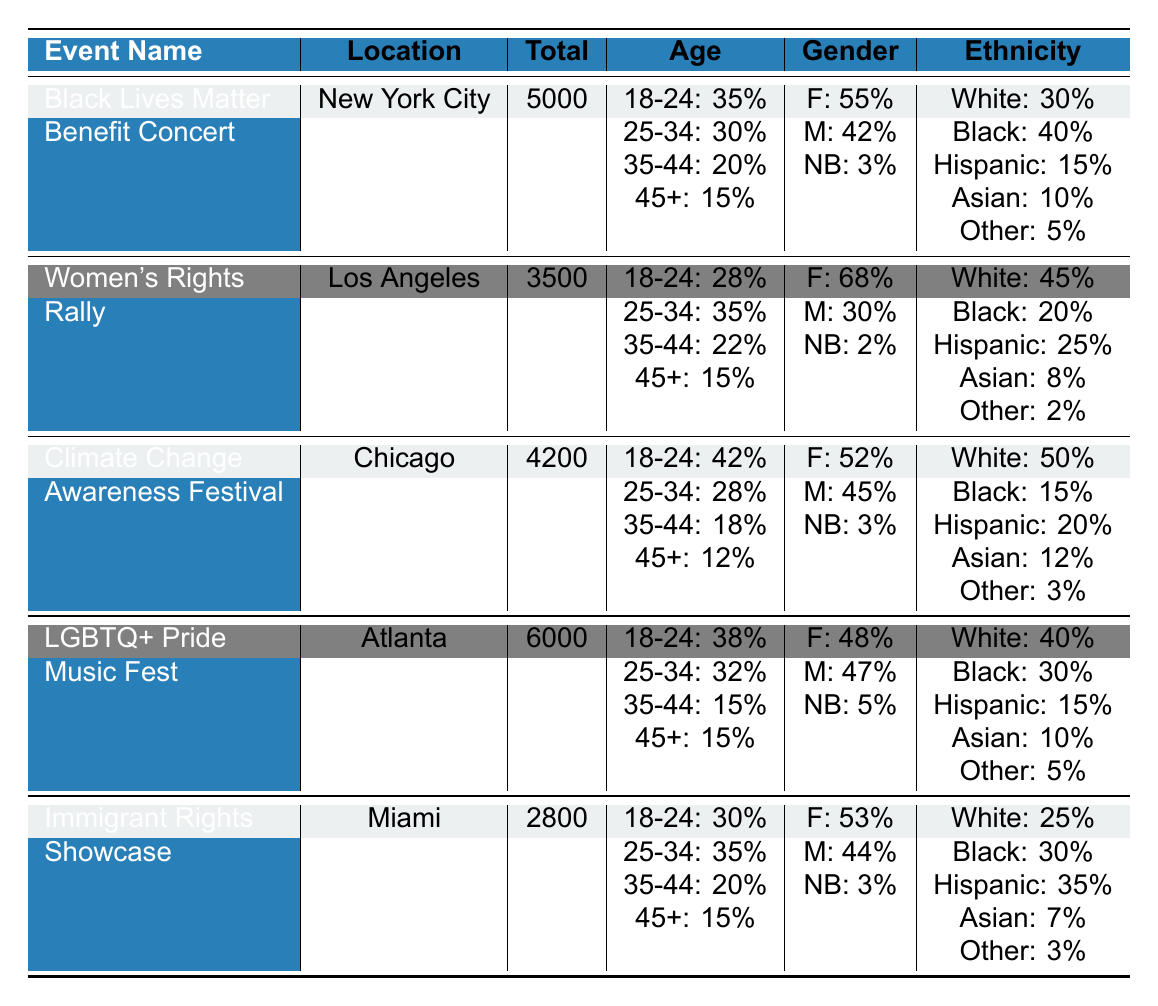What is the total number of attendees at the Women's Rights Rally? The total number of attendees is provided in the "Total Attendees" column for the Women's Rights Rally, which shows 3500 attendees.
Answer: 3500 Which event had the highest percentage of attendees aged 18-24? The "Age 18-24 Percentage" column shows the values: 35%, 28%, 42%, 38%, and 30%. The highest value is 42%, which corresponds to the Climate Change Awareness Festival.
Answer: Climate Change Awareness Festival What percentage of attendees at the LGBTQ+ Pride Music Fest identified as male? Referring to the "Male Percentage" column, the value provided for the LGBTQ+ Pride Music Fest is 47%.
Answer: 47% Is the majority of attendees at the Black Lives Matter Benefit Concert female? The "Female Percentage" for the Black Lives Matter Benefit Concert is 55%, which is greater than 50%, indicating that the majority are female.
Answer: Yes How many more attendees were there at the LGBTQ+ Pride Music Fest compared to the Immigrant Rights Showcase? The total attendees for the LGBTQ+ Pride Music Fest is 6000, while for the Immigrant Rights Showcase, it is 2800. The difference is 6000 - 2800 = 3200.
Answer: 3200 What is the average percentage of Hispanic attendees across all events? The percentages of Hispanic attendees are 15%, 25%, 20%, 15%, and 35%. Adding these gives 15 + 25 + 20 + 15 + 35 = 110. Dividing this by 5 gives an average of 110 / 5 = 22%.
Answer: 22% Which event had the lowest percentage of Asian attendees? The "Asian Percentage" values are 10%, 8%, 12%, 10%, and 7%. The lowest value is 7%, corresponding to the Immigrant Rights Showcase.
Answer: Immigrant Rights Showcase How does the percentage of Black attendees compare between the Black Lives Matter Benefit Concert and the LGBTQ+ Pride Music Fest? The percentage of Black attendees for both events is 40% and 30%, respectively. Since 40% > 30%, the Black Lives Matter Benefit Concert has a higher percentage of Black attendees.
Answer: Higher for Black Lives Matter Benefit Concert Which location hosted the event with the second highest total attendees? The highest is 6000 (LGBTQ+ Pride Music Fest), and the second highest is 5000 (Black Lives Matter Benefit Concert).
Answer: New York City What is the percentage of Non-Binary attendees at the Climate Change Awareness Festival? According to the "Non-Binary Percentage" column, the percentage is 3% for the Climate Change Awareness Festival.
Answer: 3% 